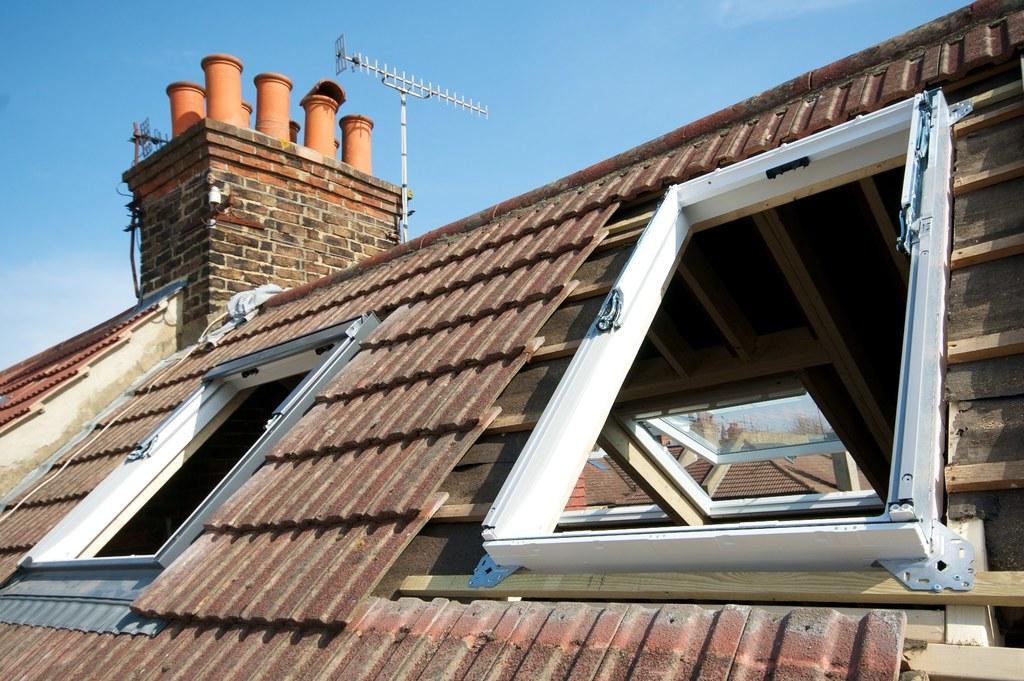Please provide a concise description of this image. In this image I can see buildings. There are glass windows, there is an antenna and in the background there is sky. 